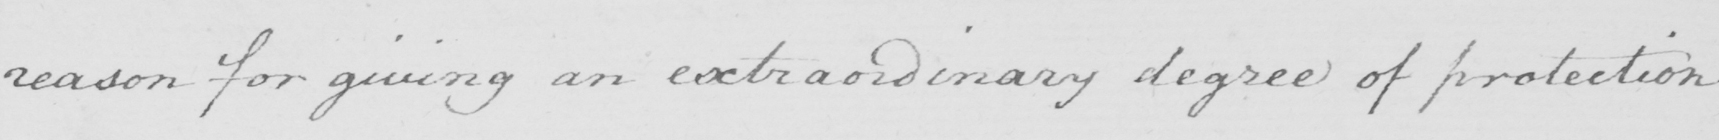Transcribe the text shown in this historical manuscript line. reason for giving an extraordinary degree of protection 